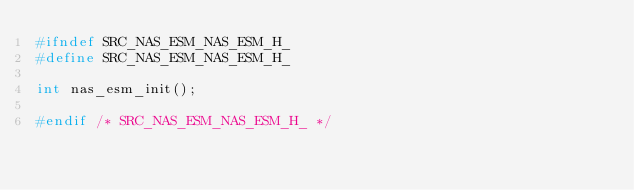Convert code to text. <code><loc_0><loc_0><loc_500><loc_500><_C_>#ifndef SRC_NAS_ESM_NAS_ESM_H_
#define SRC_NAS_ESM_NAS_ESM_H_

int nas_esm_init();

#endif /* SRC_NAS_ESM_NAS_ESM_H_ */
</code> 